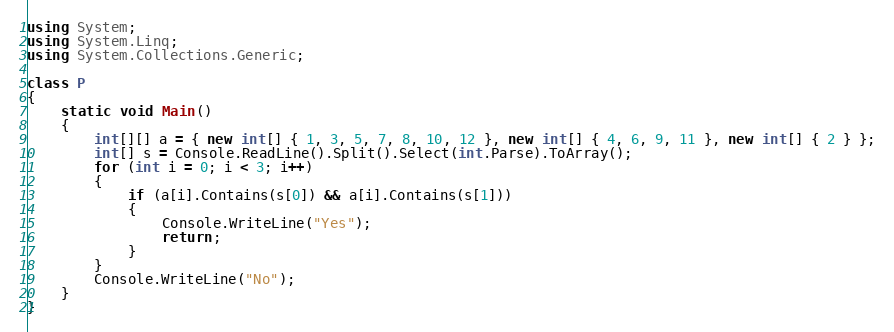<code> <loc_0><loc_0><loc_500><loc_500><_C#_>using System;
using System.Linq;
using System.Collections.Generic;

class P
{
    static void Main()
    {
        int[][] a = { new int[] { 1, 3, 5, 7, 8, 10, 12 }, new int[] { 4, 6, 9, 11 }, new int[] { 2 } };
        int[] s = Console.ReadLine().Split().Select(int.Parse).ToArray();
        for (int i = 0; i < 3; i++)
        {
            if (a[i].Contains(s[0]) && a[i].Contains(s[1]))
            {
                Console.WriteLine("Yes");
                return;
            }
        }
        Console.WriteLine("No");
    }
}</code> 